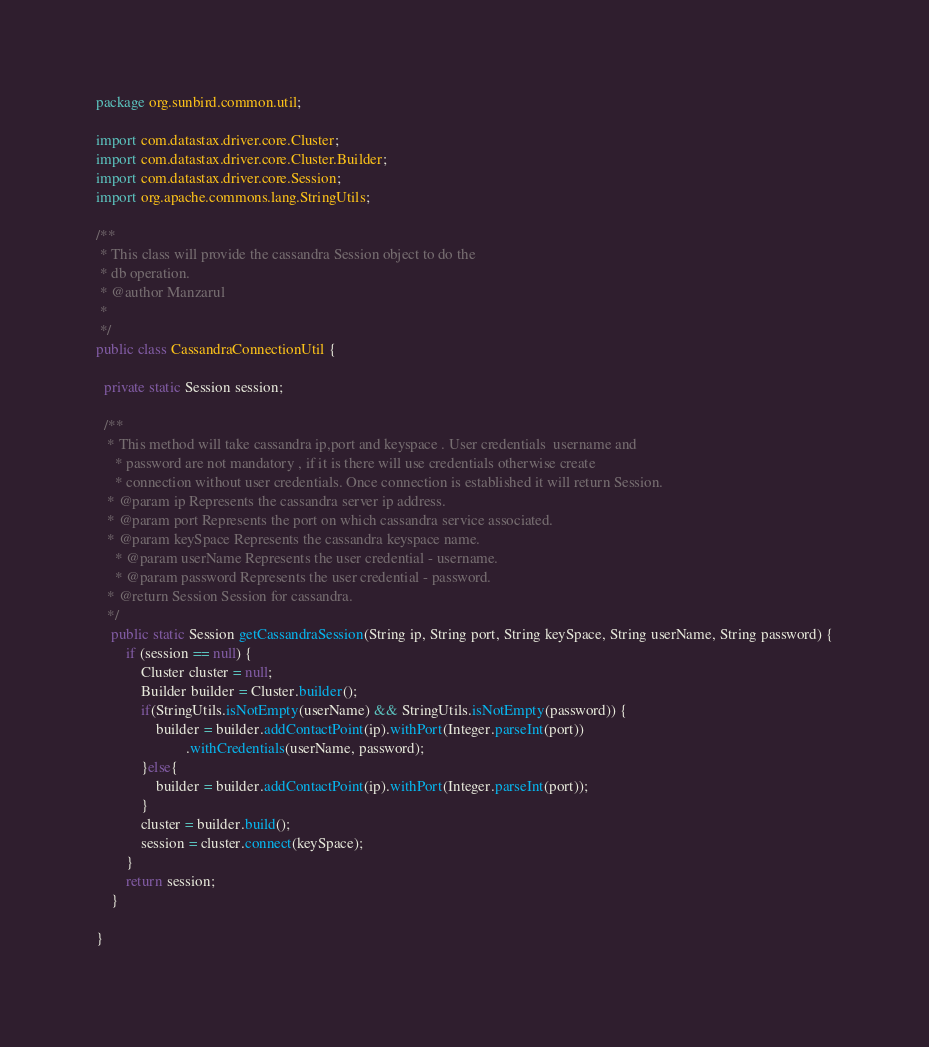Convert code to text. <code><loc_0><loc_0><loc_500><loc_500><_Java_>package org.sunbird.common.util;

import com.datastax.driver.core.Cluster;
import com.datastax.driver.core.Cluster.Builder;
import com.datastax.driver.core.Session;
import org.apache.commons.lang.StringUtils;

/**
 * This class will provide the cassandra Session object to do the
 * db operation.
 * @author Manzarul
 *
 */
public class CassandraConnectionUtil {

  private static Session session;	
	
  /**
   * This method will take cassandra ip,port and keyspace . User credentials  username and
	 * password are not mandatory , if it is there will use credentials otherwise create
	 * connection without user credentials. Once connection is established it will return Session.
   * @param ip Represents the cassandra server ip address.
   * @param port Represents the port on which cassandra service associated.
   * @param keySpace Represents the cassandra keyspace name.
	 * @param userName Represents the user credential - username.
	 * @param password Represents the user credential - password.
   * @return Session Session for cassandra.
   */
	public static Session getCassandraSession(String ip, String port, String keySpace, String userName, String password) {
		if (session == null) {
			Cluster cluster = null;
			Builder builder = Cluster.builder();
			if(StringUtils.isNotEmpty(userName) && StringUtils.isNotEmpty(password)) {
				builder = builder.addContactPoint(ip).withPort(Integer.parseInt(port))
						.withCredentials(userName, password);
			}else{
				builder = builder.addContactPoint(ip).withPort(Integer.parseInt(port));
			}
			cluster = builder.build();
			session = cluster.connect(keySpace);
		}
		return session;
	}
 
}
</code> 